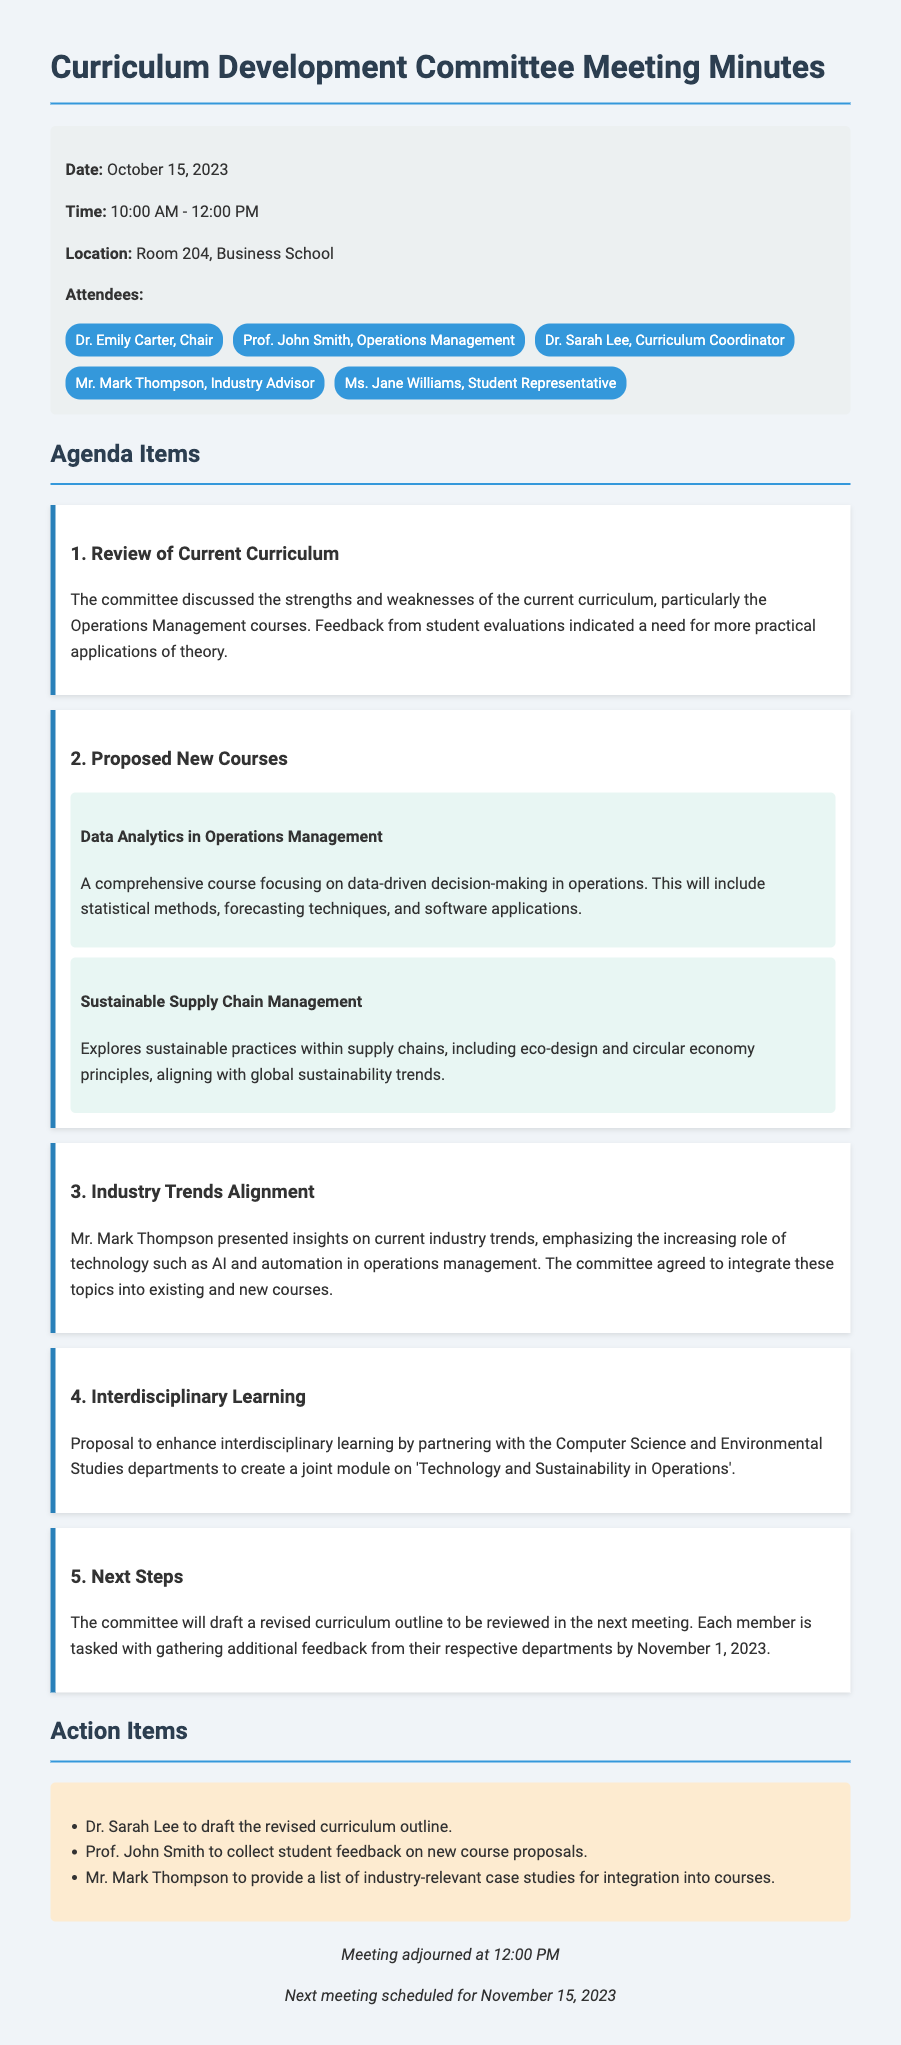What is the date of the meeting? The date of the meeting is explicitly stated in the meeting minutes.
Answer: October 15, 2023 Who is the Chair of the committee? The minutes mention Dr. Emily Carter as the Chair, highlighting her role.
Answer: Dr. Emily Carter What new course focuses on data-driven decision-making? The document lists the proposed new courses and mentions specific details about them.
Answer: Data Analytics in Operations Management What is one of the industry trends discussed during the meeting? The document indicates insights presented by Mr. Mark Thompson regarding trends in operations management.
Answer: AI and automation What will Dr. Sarah Lee draft as part of the next steps? The action items section specifies tasks assigned to committee members, including Dr. Sarah Lee.
Answer: Revised curriculum outline What is the next meeting's scheduled date? The adjournment section provides details about future meetings, including dates.
Answer: November 15, 2023 Which departments will partner for the joint module? The agenda item discusses enhancing interdisciplinary learning through partnerships.
Answer: Computer Science and Environmental Studies What are the proposed sustainable practices explored in the new course? The detailed description of the proposed course provides its focus area.
Answer: Eco-design and circular economy principles 